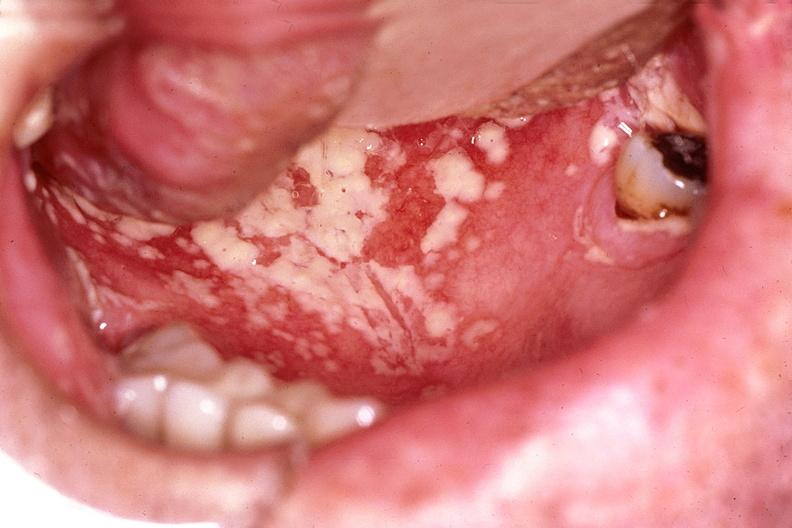where does this belong to?
Answer the question using a single word or phrase. Gastrointestinal system 